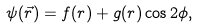<formula> <loc_0><loc_0><loc_500><loc_500>\psi ( \vec { r } ) = f ( r ) + g ( r ) \cos 2 \phi ,</formula> 